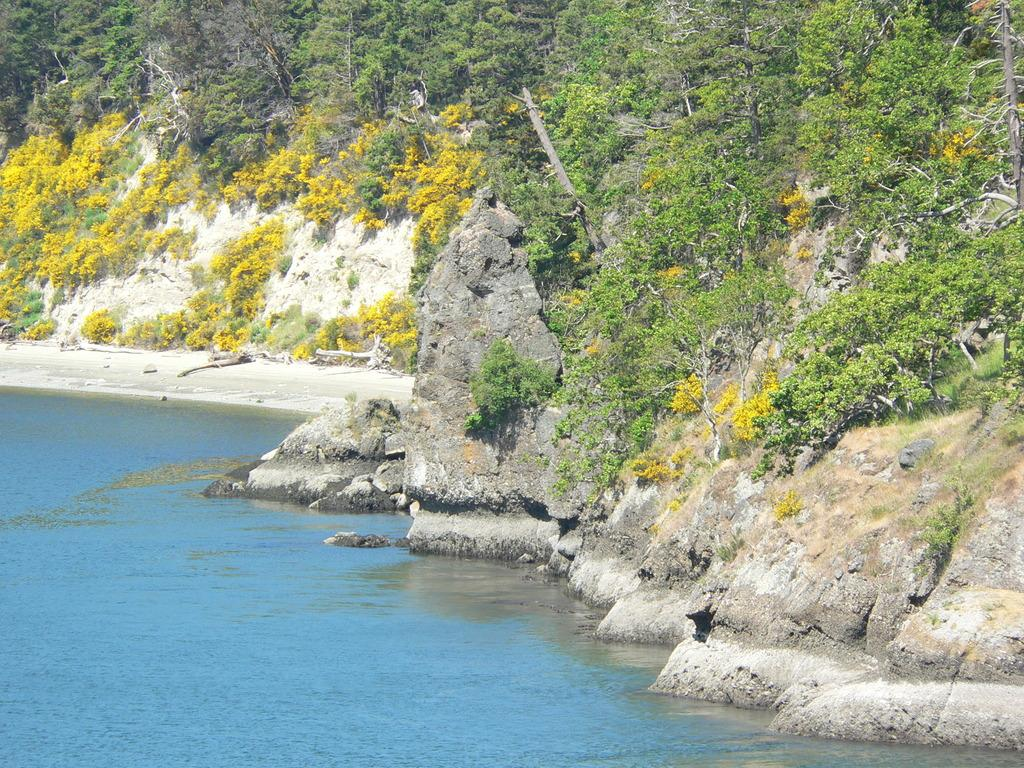What is the primary element present in the image? There is water in the image. What types of plants can be seen in the image? There are yellow and green color plants in the image. What geographical feature is visible in the image? There is a hill visible in the image. What can be seen in the background of the image? There are trees in the background of the image. How many trucks are parked near the playground in the image? There are no trucks or playground present in the image. What type of needle can be seen in the image? There is no needle present in the image. 